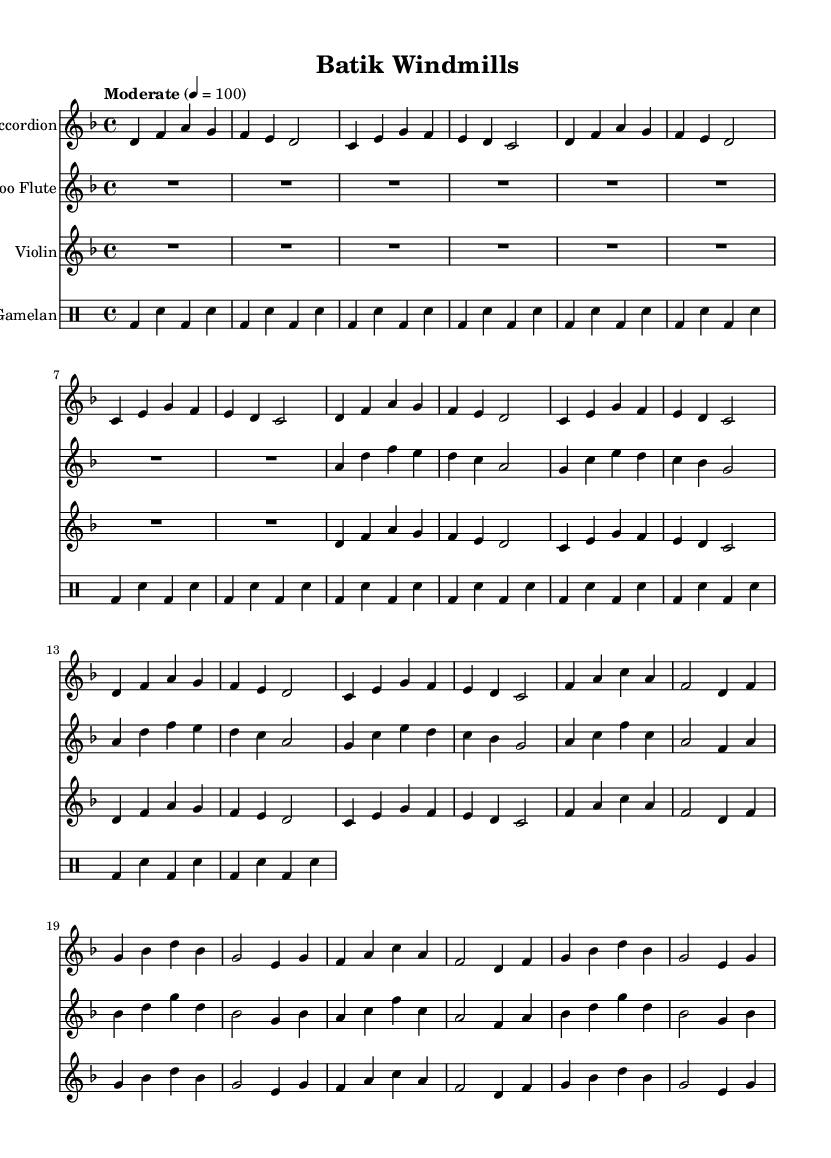What is the key signature of this music? The key signature is D minor, which contains one flat (B flat). This can be identified at the beginning of the score, where the key signature is displayed.
Answer: D minor What is the time signature of this piece? The time signature is 4/4, which means there are four beats in each measure and the quarter note gets one beat. This is indicated at the beginning of the score following the key signature.
Answer: 4/4 What is the tempo marking for this piece? The tempo marking is "Moderate" with a metronome marking of 100 beats per minute. The tempo is specified at the top of the score after the time signature.
Answer: Moderate, 100 How many measures are in the introduction section? The introduction section contains 8 measures, as counted from the start of the accordion part until the section ends. Each measure is marked by vertical lines in the sheet music.
Answer: 8 What instruments are featured in this composition? The composition features four instruments: Accordion, Bamboo Flute, Violin, and Gamelan. Each instrument has its own staff labeled at the beginning of the respective sections in the score.
Answer: Accordion, Bamboo Flute, Violin, Gamelan What fusion elements are evident in this musical piece? The fusion elements evident in this piece include typical Western harmonies and structure from the Dutch tradition combined with Gamelan rhythms and bamboo flute melodies from Indonesian music. This blending can be deduced from the instrumentation and rhythmic patterns presented in the score.
Answer: Western and Indonesian 